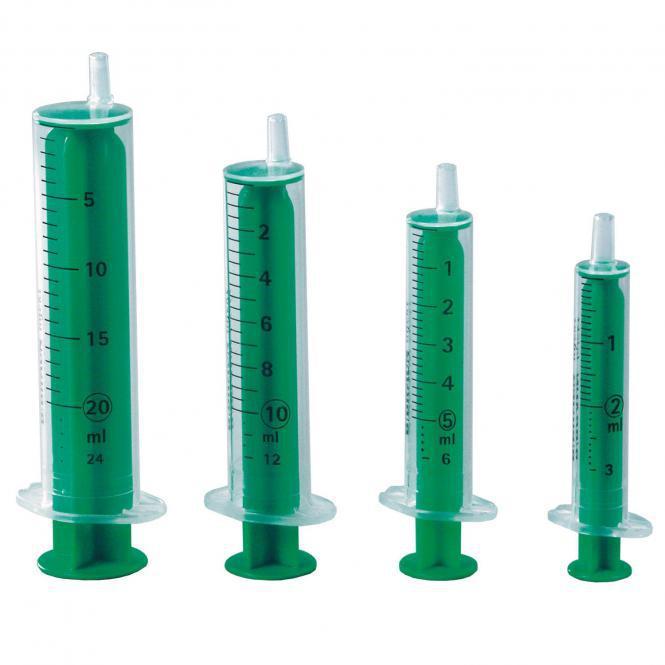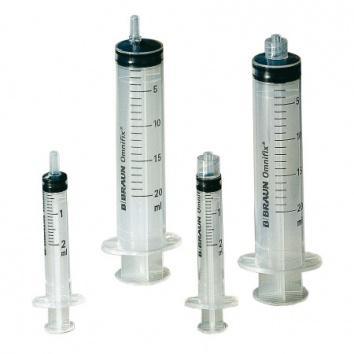The first image is the image on the left, the second image is the image on the right. Assess this claim about the two images: "There are the same amount of syringes in the image on the left as in the image on the right.". Correct or not? Answer yes or no. Yes. The first image is the image on the left, the second image is the image on the right. Examine the images to the left and right. Is the description "Right and left images contain the same number of syringe-type items." accurate? Answer yes or no. Yes. 